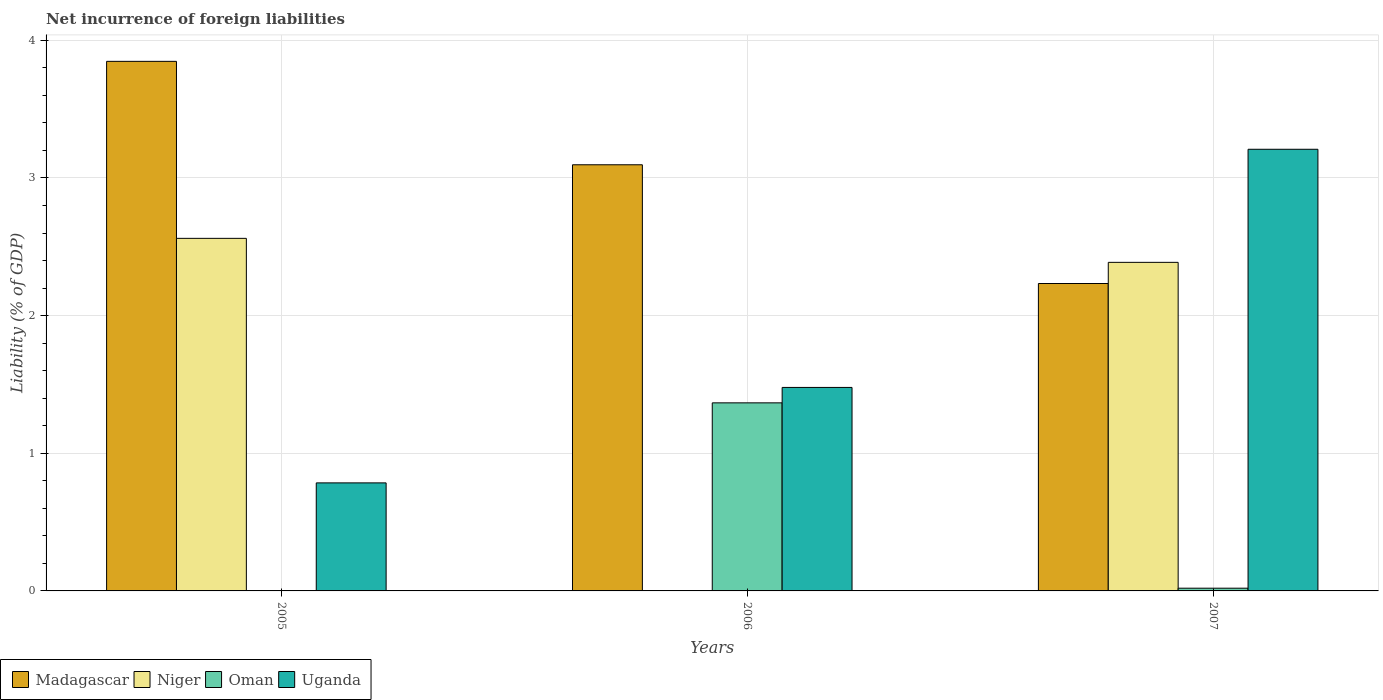How many groups of bars are there?
Make the answer very short. 3. What is the net incurrence of foreign liabilities in Niger in 2007?
Your response must be concise. 2.39. Across all years, what is the maximum net incurrence of foreign liabilities in Uganda?
Offer a very short reply. 3.21. Across all years, what is the minimum net incurrence of foreign liabilities in Madagascar?
Provide a succinct answer. 2.23. In which year was the net incurrence of foreign liabilities in Madagascar maximum?
Your answer should be very brief. 2005. What is the total net incurrence of foreign liabilities in Niger in the graph?
Your answer should be compact. 4.95. What is the difference between the net incurrence of foreign liabilities in Oman in 2006 and that in 2007?
Your response must be concise. 1.35. What is the difference between the net incurrence of foreign liabilities in Madagascar in 2007 and the net incurrence of foreign liabilities in Uganda in 2005?
Provide a short and direct response. 1.45. What is the average net incurrence of foreign liabilities in Niger per year?
Your response must be concise. 1.65. In the year 2006, what is the difference between the net incurrence of foreign liabilities in Oman and net incurrence of foreign liabilities in Uganda?
Your response must be concise. -0.11. In how many years, is the net incurrence of foreign liabilities in Madagascar greater than 3.8 %?
Offer a very short reply. 1. What is the ratio of the net incurrence of foreign liabilities in Madagascar in 2005 to that in 2006?
Ensure brevity in your answer.  1.24. What is the difference between the highest and the second highest net incurrence of foreign liabilities in Madagascar?
Ensure brevity in your answer.  0.75. What is the difference between the highest and the lowest net incurrence of foreign liabilities in Niger?
Give a very brief answer. 2.56. In how many years, is the net incurrence of foreign liabilities in Niger greater than the average net incurrence of foreign liabilities in Niger taken over all years?
Make the answer very short. 2. Is the sum of the net incurrence of foreign liabilities in Uganda in 2006 and 2007 greater than the maximum net incurrence of foreign liabilities in Oman across all years?
Ensure brevity in your answer.  Yes. Is it the case that in every year, the sum of the net incurrence of foreign liabilities in Oman and net incurrence of foreign liabilities in Madagascar is greater than the sum of net incurrence of foreign liabilities in Niger and net incurrence of foreign liabilities in Uganda?
Provide a short and direct response. No. How many years are there in the graph?
Your answer should be compact. 3. What is the difference between two consecutive major ticks on the Y-axis?
Your answer should be compact. 1. Does the graph contain any zero values?
Provide a succinct answer. Yes. Does the graph contain grids?
Your answer should be compact. Yes. Where does the legend appear in the graph?
Provide a short and direct response. Bottom left. How many legend labels are there?
Your answer should be compact. 4. How are the legend labels stacked?
Offer a very short reply. Horizontal. What is the title of the graph?
Offer a very short reply. Net incurrence of foreign liabilities. Does "Uzbekistan" appear as one of the legend labels in the graph?
Your answer should be compact. No. What is the label or title of the Y-axis?
Your answer should be very brief. Liability (% of GDP). What is the Liability (% of GDP) in Madagascar in 2005?
Offer a very short reply. 3.85. What is the Liability (% of GDP) of Niger in 2005?
Provide a short and direct response. 2.56. What is the Liability (% of GDP) in Oman in 2005?
Provide a short and direct response. 0. What is the Liability (% of GDP) in Uganda in 2005?
Your answer should be compact. 0.78. What is the Liability (% of GDP) of Madagascar in 2006?
Offer a terse response. 3.1. What is the Liability (% of GDP) in Oman in 2006?
Provide a short and direct response. 1.37. What is the Liability (% of GDP) of Uganda in 2006?
Ensure brevity in your answer.  1.48. What is the Liability (% of GDP) of Madagascar in 2007?
Keep it short and to the point. 2.23. What is the Liability (% of GDP) of Niger in 2007?
Give a very brief answer. 2.39. What is the Liability (% of GDP) of Oman in 2007?
Make the answer very short. 0.02. What is the Liability (% of GDP) in Uganda in 2007?
Ensure brevity in your answer.  3.21. Across all years, what is the maximum Liability (% of GDP) of Madagascar?
Your answer should be very brief. 3.85. Across all years, what is the maximum Liability (% of GDP) of Niger?
Ensure brevity in your answer.  2.56. Across all years, what is the maximum Liability (% of GDP) in Oman?
Your response must be concise. 1.37. Across all years, what is the maximum Liability (% of GDP) of Uganda?
Provide a succinct answer. 3.21. Across all years, what is the minimum Liability (% of GDP) in Madagascar?
Your answer should be very brief. 2.23. Across all years, what is the minimum Liability (% of GDP) in Oman?
Ensure brevity in your answer.  0. Across all years, what is the minimum Liability (% of GDP) of Uganda?
Your answer should be compact. 0.78. What is the total Liability (% of GDP) of Madagascar in the graph?
Provide a short and direct response. 9.18. What is the total Liability (% of GDP) of Niger in the graph?
Offer a very short reply. 4.95. What is the total Liability (% of GDP) in Oman in the graph?
Keep it short and to the point. 1.39. What is the total Liability (% of GDP) of Uganda in the graph?
Offer a terse response. 5.47. What is the difference between the Liability (% of GDP) in Madagascar in 2005 and that in 2006?
Offer a terse response. 0.75. What is the difference between the Liability (% of GDP) of Uganda in 2005 and that in 2006?
Provide a succinct answer. -0.69. What is the difference between the Liability (% of GDP) in Madagascar in 2005 and that in 2007?
Offer a very short reply. 1.61. What is the difference between the Liability (% of GDP) of Niger in 2005 and that in 2007?
Your response must be concise. 0.17. What is the difference between the Liability (% of GDP) of Uganda in 2005 and that in 2007?
Give a very brief answer. -2.42. What is the difference between the Liability (% of GDP) in Madagascar in 2006 and that in 2007?
Provide a short and direct response. 0.86. What is the difference between the Liability (% of GDP) of Oman in 2006 and that in 2007?
Offer a terse response. 1.35. What is the difference between the Liability (% of GDP) in Uganda in 2006 and that in 2007?
Make the answer very short. -1.73. What is the difference between the Liability (% of GDP) in Madagascar in 2005 and the Liability (% of GDP) in Oman in 2006?
Provide a succinct answer. 2.48. What is the difference between the Liability (% of GDP) of Madagascar in 2005 and the Liability (% of GDP) of Uganda in 2006?
Give a very brief answer. 2.37. What is the difference between the Liability (% of GDP) of Niger in 2005 and the Liability (% of GDP) of Oman in 2006?
Offer a terse response. 1.19. What is the difference between the Liability (% of GDP) in Niger in 2005 and the Liability (% of GDP) in Uganda in 2006?
Your response must be concise. 1.08. What is the difference between the Liability (% of GDP) in Madagascar in 2005 and the Liability (% of GDP) in Niger in 2007?
Your answer should be compact. 1.46. What is the difference between the Liability (% of GDP) in Madagascar in 2005 and the Liability (% of GDP) in Oman in 2007?
Make the answer very short. 3.83. What is the difference between the Liability (% of GDP) of Madagascar in 2005 and the Liability (% of GDP) of Uganda in 2007?
Provide a short and direct response. 0.64. What is the difference between the Liability (% of GDP) of Niger in 2005 and the Liability (% of GDP) of Oman in 2007?
Offer a very short reply. 2.54. What is the difference between the Liability (% of GDP) of Niger in 2005 and the Liability (% of GDP) of Uganda in 2007?
Offer a very short reply. -0.65. What is the difference between the Liability (% of GDP) of Madagascar in 2006 and the Liability (% of GDP) of Niger in 2007?
Your answer should be very brief. 0.71. What is the difference between the Liability (% of GDP) in Madagascar in 2006 and the Liability (% of GDP) in Oman in 2007?
Provide a short and direct response. 3.08. What is the difference between the Liability (% of GDP) in Madagascar in 2006 and the Liability (% of GDP) in Uganda in 2007?
Offer a terse response. -0.11. What is the difference between the Liability (% of GDP) of Oman in 2006 and the Liability (% of GDP) of Uganda in 2007?
Ensure brevity in your answer.  -1.84. What is the average Liability (% of GDP) in Madagascar per year?
Make the answer very short. 3.06. What is the average Liability (% of GDP) in Niger per year?
Your answer should be compact. 1.65. What is the average Liability (% of GDP) in Oman per year?
Give a very brief answer. 0.46. What is the average Liability (% of GDP) in Uganda per year?
Provide a short and direct response. 1.82. In the year 2005, what is the difference between the Liability (% of GDP) of Madagascar and Liability (% of GDP) of Niger?
Your answer should be compact. 1.29. In the year 2005, what is the difference between the Liability (% of GDP) in Madagascar and Liability (% of GDP) in Uganda?
Give a very brief answer. 3.06. In the year 2005, what is the difference between the Liability (% of GDP) in Niger and Liability (% of GDP) in Uganda?
Your response must be concise. 1.78. In the year 2006, what is the difference between the Liability (% of GDP) in Madagascar and Liability (% of GDP) in Oman?
Give a very brief answer. 1.73. In the year 2006, what is the difference between the Liability (% of GDP) of Madagascar and Liability (% of GDP) of Uganda?
Ensure brevity in your answer.  1.62. In the year 2006, what is the difference between the Liability (% of GDP) of Oman and Liability (% of GDP) of Uganda?
Offer a very short reply. -0.11. In the year 2007, what is the difference between the Liability (% of GDP) of Madagascar and Liability (% of GDP) of Niger?
Ensure brevity in your answer.  -0.15. In the year 2007, what is the difference between the Liability (% of GDP) of Madagascar and Liability (% of GDP) of Oman?
Your response must be concise. 2.21. In the year 2007, what is the difference between the Liability (% of GDP) of Madagascar and Liability (% of GDP) of Uganda?
Your answer should be compact. -0.98. In the year 2007, what is the difference between the Liability (% of GDP) of Niger and Liability (% of GDP) of Oman?
Offer a very short reply. 2.37. In the year 2007, what is the difference between the Liability (% of GDP) in Niger and Liability (% of GDP) in Uganda?
Your answer should be very brief. -0.82. In the year 2007, what is the difference between the Liability (% of GDP) of Oman and Liability (% of GDP) of Uganda?
Your answer should be compact. -3.19. What is the ratio of the Liability (% of GDP) in Madagascar in 2005 to that in 2006?
Your answer should be very brief. 1.24. What is the ratio of the Liability (% of GDP) in Uganda in 2005 to that in 2006?
Provide a succinct answer. 0.53. What is the ratio of the Liability (% of GDP) in Madagascar in 2005 to that in 2007?
Your answer should be compact. 1.72. What is the ratio of the Liability (% of GDP) of Niger in 2005 to that in 2007?
Give a very brief answer. 1.07. What is the ratio of the Liability (% of GDP) of Uganda in 2005 to that in 2007?
Offer a terse response. 0.24. What is the ratio of the Liability (% of GDP) of Madagascar in 2006 to that in 2007?
Offer a terse response. 1.39. What is the ratio of the Liability (% of GDP) in Oman in 2006 to that in 2007?
Your response must be concise. 69.09. What is the ratio of the Liability (% of GDP) in Uganda in 2006 to that in 2007?
Ensure brevity in your answer.  0.46. What is the difference between the highest and the second highest Liability (% of GDP) of Madagascar?
Your answer should be very brief. 0.75. What is the difference between the highest and the second highest Liability (% of GDP) in Uganda?
Keep it short and to the point. 1.73. What is the difference between the highest and the lowest Liability (% of GDP) in Madagascar?
Provide a short and direct response. 1.61. What is the difference between the highest and the lowest Liability (% of GDP) of Niger?
Your response must be concise. 2.56. What is the difference between the highest and the lowest Liability (% of GDP) in Oman?
Give a very brief answer. 1.37. What is the difference between the highest and the lowest Liability (% of GDP) in Uganda?
Your response must be concise. 2.42. 